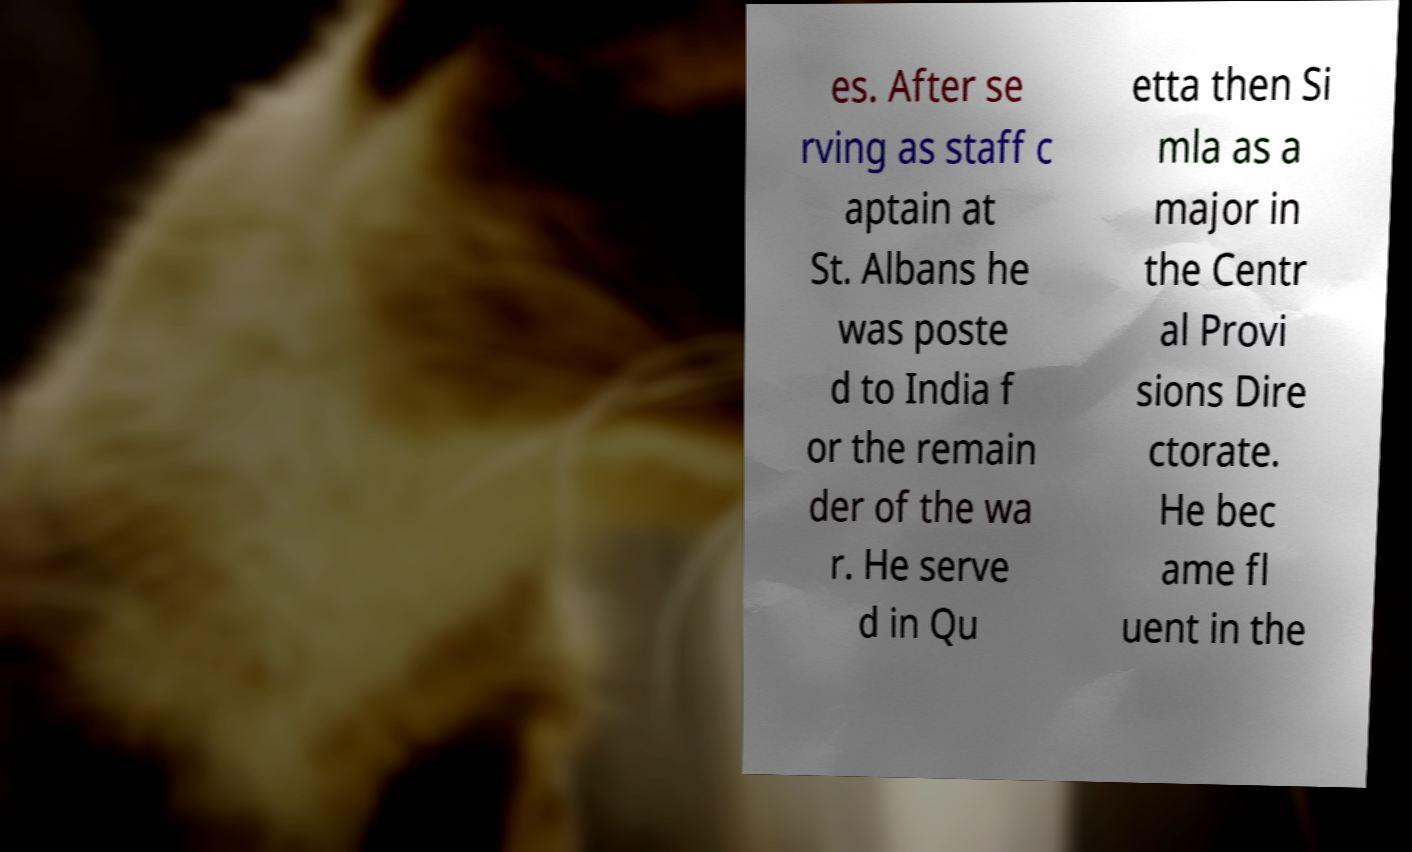I need the written content from this picture converted into text. Can you do that? es. After se rving as staff c aptain at St. Albans he was poste d to India f or the remain der of the wa r. He serve d in Qu etta then Si mla as a major in the Centr al Provi sions Dire ctorate. He bec ame fl uent in the 